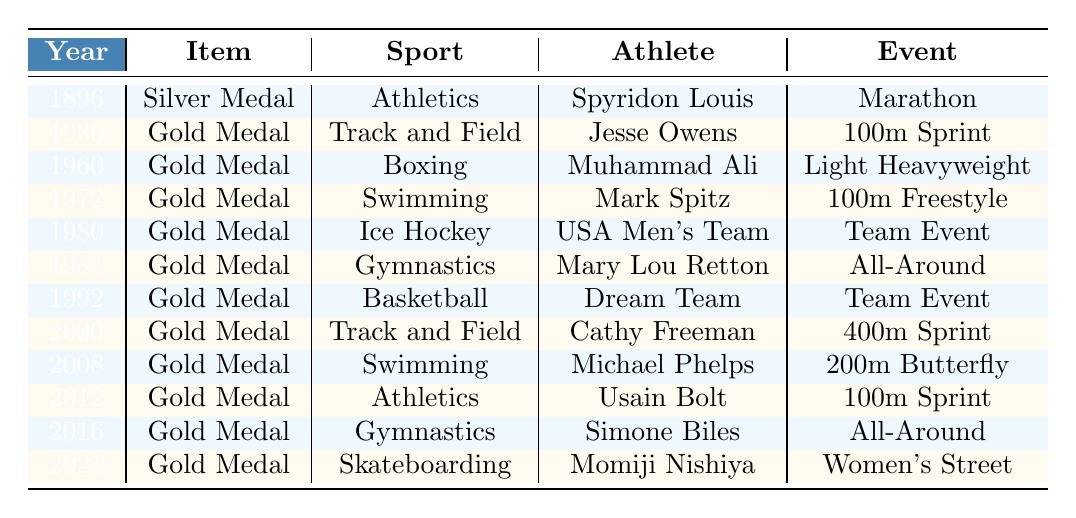What year was the Silver Medal from the First Modern Olympics acquired? The table lists the Silver Medal from the First Modern Olympics under the year 1896.
Answer: 1896 Who won the Gold Medal in Track and Field in 1936? The table shows that Jesse Owens won the Gold Medal in Track and Field during the 1936 Olympics.
Answer: Jesse Owens How many Gold Medals are listed for the sport of Swimming? The table includes two Gold Medals for Swimming, won by Mark Spitz in 1972 and Michael Phelps in 2008.
Answer: 2 In what year did Muhammad Ali win his Gold Medal? According to the table, Muhammad Ali won his Gold Medal in 1960.
Answer: 1960 Were there any Gold Medals won in Basketball? Yes, the "Dream Team" won a Gold Medal in Basketball in 1992, as indicated in the table.
Answer: Yes Which sport had the latest Gold Medal acquisition according to the table? The latest Gold Medal acquisition in the table is in Skateboarding, won by Momiji Nishiya in 2021.
Answer: Skateboarding What is the total number of unique sports represented in the Gold Medals? The unique sports represented in the Gold Medals are: Track and Field, Boxing, Swimming, Ice Hockey, Gymnastics, Basketball, and Skateboarding. This totals to 7 distinct sports.
Answer: 7 Between which years did the museum acquire the significant medals? The first acquisition was in 1896 and the last one in 2021, making the range from 1896 to 2021.
Answer: 1896 to 2021 Who participated in the 1980 Ice Hockey event listed in the table? The table indicates that the USA Men's Team participated in the Team Event for Ice Hockey in 1980.
Answer: USA Men's Team Which athlete has the most recent Gold Medal from the collection? Momiji Nishiya, who won the Gold Medal in Skateboarding in 2021, has the most recent medal according to the table.
Answer: Momiji Nishiya Which sport does not have a Gold Medal listed for an individual athlete? The sport of Ice Hockey does not have a Gold Medal listed for an individual athlete; it's attributed to the USA Men's Team.
Answer: Ice Hockey How many Gold Medals were won in Athletics? There are three Gold Medals listed for Athletics in the table: by Spyridon Louis in 1896, Usain Bolt in 2012, and one Gold Medal is in Gymnastics; it was not counted.
Answer: 3 Identify the earliest event noted in the collection and the athlete associated with it. The earliest event noted in the collection is the Marathon from the 1896 Olympics, associated with athlete Spyridon Louis.
Answer: Spyridon Louis What is the significance of the year 2000 in this collection? The year 2000 is significant as it shows the Gold Medal won by Cathy Freeman in Track and Field, marking a notable event in the Olympics.
Answer: Gold Medal by Cathy Freeman in Track and Field 